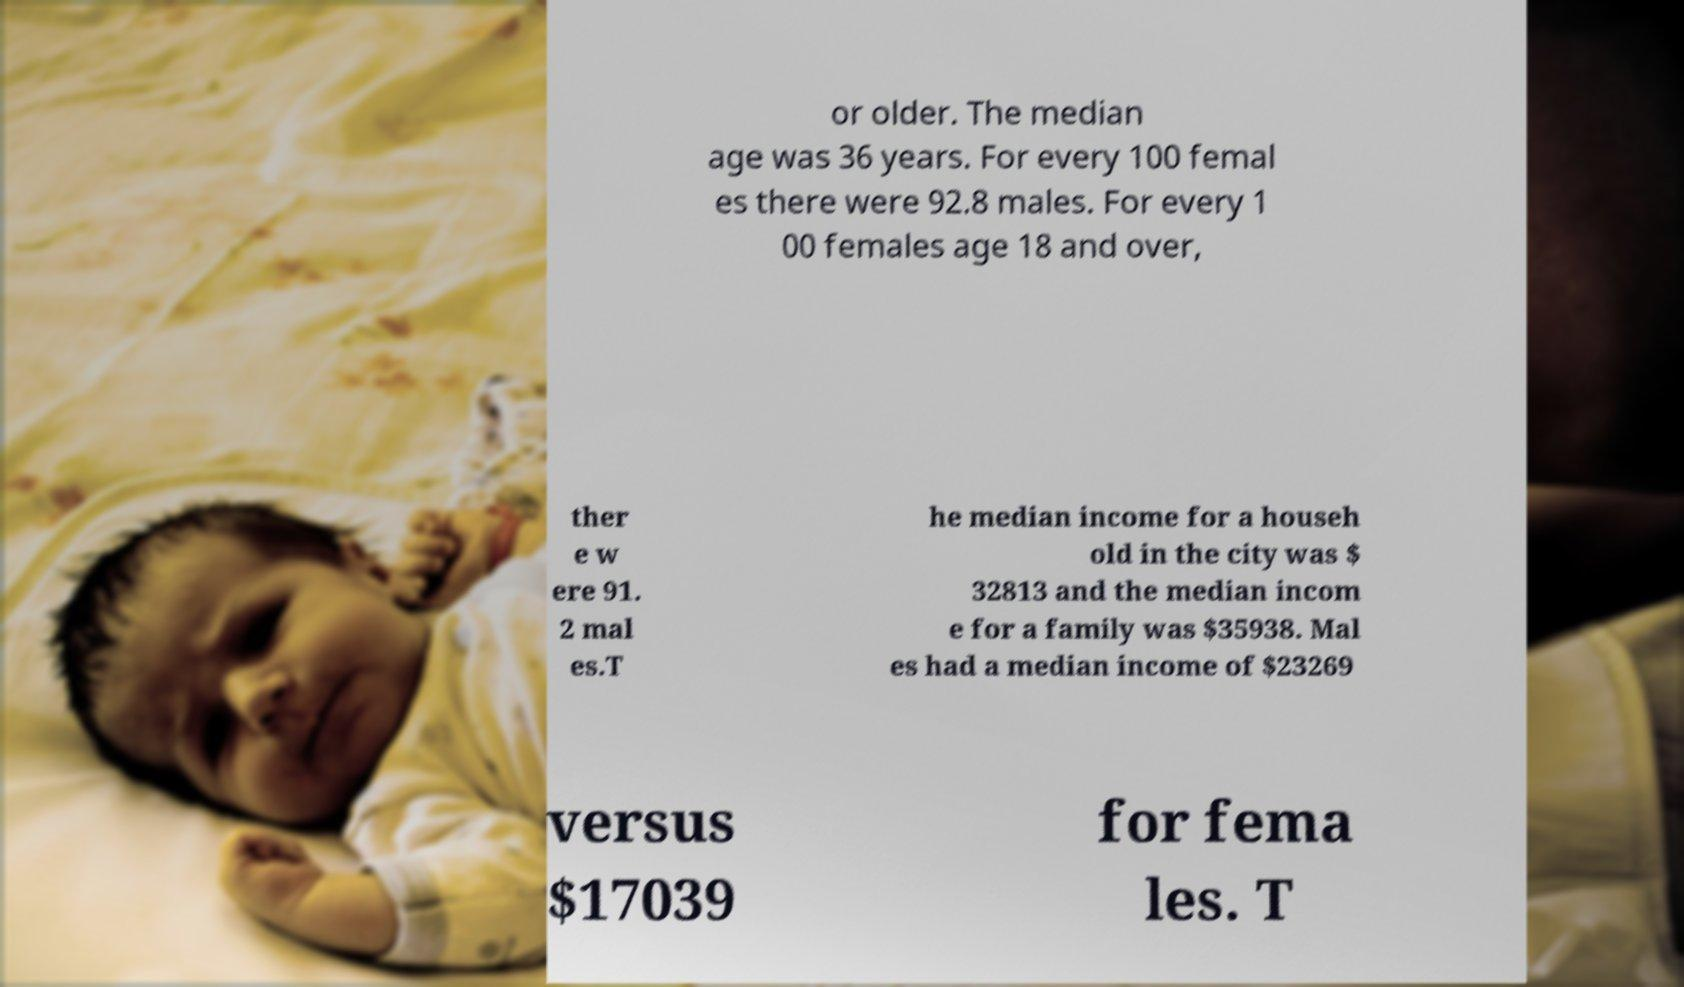Please read and relay the text visible in this image. What does it say? or older. The median age was 36 years. For every 100 femal es there were 92.8 males. For every 1 00 females age 18 and over, ther e w ere 91. 2 mal es.T he median income for a househ old in the city was $ 32813 and the median incom e for a family was $35938. Mal es had a median income of $23269 versus $17039 for fema les. T 